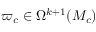<formula> <loc_0><loc_0><loc_500><loc_500>\varpi _ { c } \in \Omega ^ { k + 1 } ( M _ { c } )</formula> 